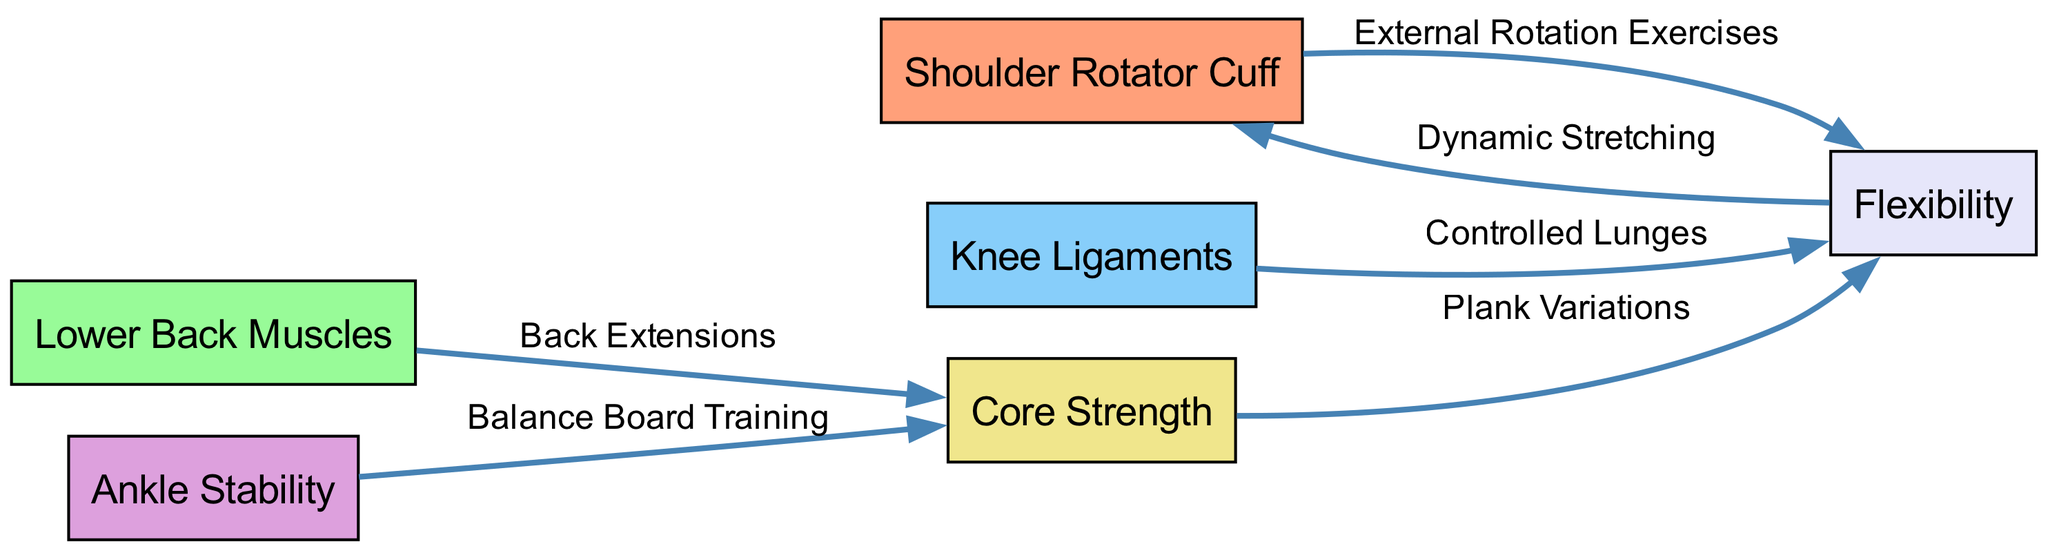What are the main muscle groups addressed in the diagram? The diagram lists six muscle groups: Shoulder Rotator Cuff, Lower Back Muscles, Knee Ligaments, Ankle Stability, Core Strength, and Flexibility.
Answer: Shoulder Rotator Cuff, Lower Back Muscles, Knee Ligaments, Ankle Stability, Core Strength, Flexibility How many edges are shown in the diagram? The diagram contains five edges that represent the relationships between the nodes. Counting the lines connecting the nodes yields a total of five edges.
Answer: 5 What exercise is connected to the Shoulder Rotator Cuff? The exercise labeled as "External Rotation Exercises" is connected to the Shoulder Rotator Cuff node. This relationship indicates the specific rehabilitation activity for that muscle group.
Answer: External Rotation Exercises Which muscle group is targeted by 'Balance Board Training'? The 'Balance Board Training' exercise targets the Ankle Stability muscle group, as indicated by the edge connecting these two nodes in the diagram.
Answer: Ankle Stability What is the relationship between Core Strength and Flexibility? The edge connecting Core Strength and Flexibility indicates that the exercise involved is "Plank Variations," which implies that improving core strength also enhances flexibility through this particular activity.
Answer: Plank Variations What are the two exercises that link to Flexibility in the diagram? Flexibility connects to two exercises in the diagram: "Controlled Lunges" from Knee Ligaments and "Dynamic Stretching" from Flexibility itself, illustrating the exercises aimed at improving flexibility related to the muscle groups.
Answer: Controlled Lunges, Dynamic Stretching What type of training is indicated for Lower Back Muscles? The training for Lower Back Muscles is identified as "Back Extensions," highlighting a specific rehabilitation exercise linked to this muscle group in the diagram.
Answer: Back Extensions Which node has the most connections? The Core Strength node has the most connections, linked to both Lower Back Muscles and Flexibility as indicated in the diagram's structure.
Answer: Core Strength 